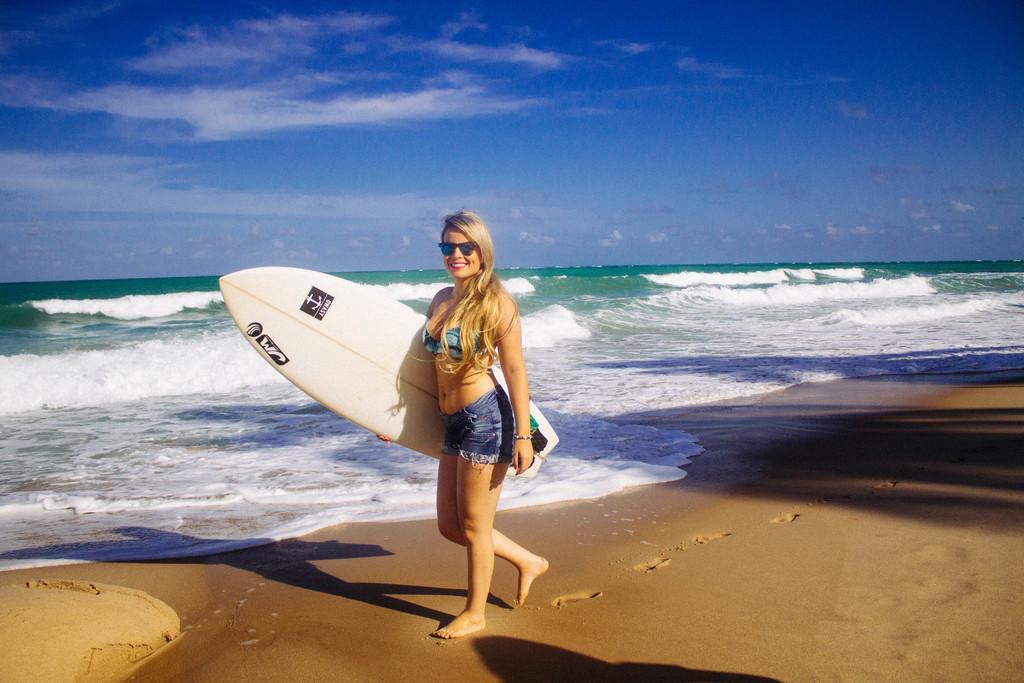Please provide a concise description of this image. In this image I can see a person holding the surfing board. Background there is a water and the sky. 